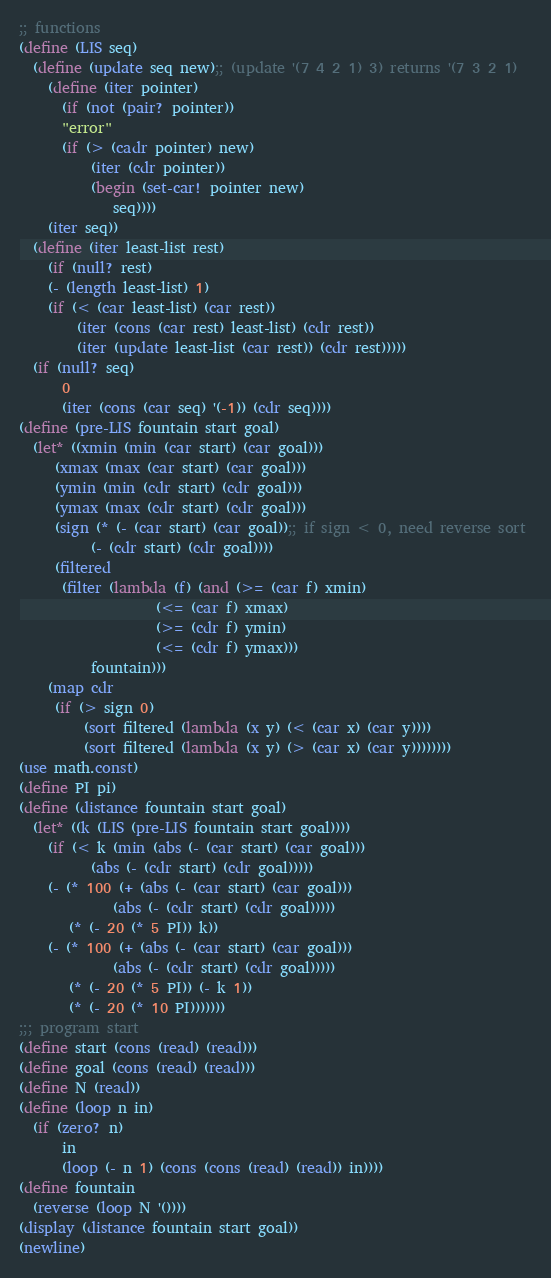<code> <loc_0><loc_0><loc_500><loc_500><_Scheme_>;; functions
(define (LIS seq)
  (define (update seq new);; (update '(7 4 2 1) 3) returns '(7 3 2 1)
    (define (iter pointer)
      (if (not (pair? pointer))
	  "error"
	  (if (> (cadr pointer) new)
	      (iter (cdr pointer))
	      (begin (set-car! pointer new)
		     seq))))
    (iter seq))
  (define (iter least-list rest)
    (if (null? rest)
	(- (length least-list) 1)
	(if (< (car least-list) (car rest))
	    (iter (cons (car rest) least-list) (cdr rest))	  
	    (iter (update least-list (car rest)) (cdr rest)))))
  (if (null? seq)
      0
      (iter (cons (car seq) '(-1)) (cdr seq))))
(define (pre-LIS fountain start goal)
  (let* ((xmin (min (car start) (car goal)))
	 (xmax (max (car start) (car goal)))
	 (ymin (min (cdr start) (cdr goal)))
	 (ymax (max (cdr start) (cdr goal)))
	 (sign (* (- (car start) (car goal));; if sign < 0, need reverse sort 
		  (- (cdr start) (cdr goal))))
	 (filtered 
	  (filter (lambda (f) (and (>= (car f) xmin)
				   (<= (car f) xmax)
				   (>= (cdr f) ymin)
				   (<= (cdr f) ymax)))
		  fountain)))
    (map cdr
	 (if (> sign 0)
	     (sort filtered (lambda (x y) (< (car x) (car y)))) 
	     (sort filtered (lambda (x y) (> (car x) (car y))))))))
(use math.const)
(define PI pi)
(define (distance fountain start goal)
  (let* ((k (LIS (pre-LIS fountain start goal))))
    (if (< k (min (abs (- (car start) (car goal)))
		  (abs (- (cdr start) (cdr goal)))))
	(- (* 100 (+ (abs (- (car start) (car goal)))
		     (abs (- (cdr start) (cdr goal)))))	   
	   (* (- 20 (* 5 PI)) k))
	(- (* 100 (+ (abs (- (car start) (car goal)))
		     (abs (- (cdr start) (cdr goal)))))	   
	   (* (- 20 (* 5 PI)) (- k 1))
	   (* (- 20 (* 10 PI)))))))
;;; program start
(define start (cons (read) (read)))
(define goal (cons (read) (read)))
(define N (read))
(define (loop n in)
  (if (zero? n)
      in
      (loop (- n 1) (cons (cons (read) (read)) in))))
(define fountain
  (reverse (loop N '())))
(display (distance fountain start goal))
(newline)</code> 